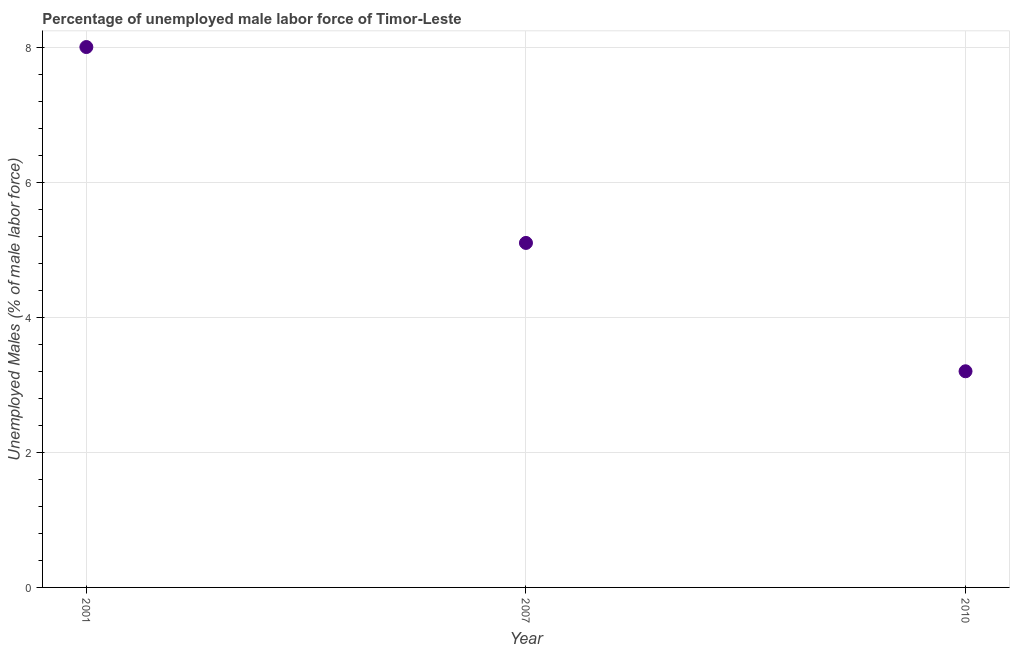What is the total unemployed male labour force in 2007?
Ensure brevity in your answer.  5.1. Across all years, what is the maximum total unemployed male labour force?
Keep it short and to the point. 8. Across all years, what is the minimum total unemployed male labour force?
Give a very brief answer. 3.2. In which year was the total unemployed male labour force maximum?
Offer a terse response. 2001. In which year was the total unemployed male labour force minimum?
Your answer should be compact. 2010. What is the sum of the total unemployed male labour force?
Your answer should be very brief. 16.3. What is the difference between the total unemployed male labour force in 2007 and 2010?
Offer a terse response. 1.9. What is the average total unemployed male labour force per year?
Provide a succinct answer. 5.43. What is the median total unemployed male labour force?
Your answer should be compact. 5.1. Do a majority of the years between 2001 and 2007 (inclusive) have total unemployed male labour force greater than 4 %?
Offer a terse response. Yes. What is the ratio of the total unemployed male labour force in 2007 to that in 2010?
Your answer should be very brief. 1.59. Is the total unemployed male labour force in 2001 less than that in 2010?
Your answer should be compact. No. What is the difference between the highest and the second highest total unemployed male labour force?
Offer a very short reply. 2.9. What is the difference between the highest and the lowest total unemployed male labour force?
Offer a terse response. 4.8. In how many years, is the total unemployed male labour force greater than the average total unemployed male labour force taken over all years?
Your answer should be very brief. 1. How many dotlines are there?
Offer a very short reply. 1. What is the difference between two consecutive major ticks on the Y-axis?
Keep it short and to the point. 2. Are the values on the major ticks of Y-axis written in scientific E-notation?
Keep it short and to the point. No. Does the graph contain grids?
Ensure brevity in your answer.  Yes. What is the title of the graph?
Offer a very short reply. Percentage of unemployed male labor force of Timor-Leste. What is the label or title of the Y-axis?
Keep it short and to the point. Unemployed Males (% of male labor force). What is the Unemployed Males (% of male labor force) in 2001?
Give a very brief answer. 8. What is the Unemployed Males (% of male labor force) in 2007?
Provide a succinct answer. 5.1. What is the Unemployed Males (% of male labor force) in 2010?
Your answer should be very brief. 3.2. What is the difference between the Unemployed Males (% of male labor force) in 2001 and 2010?
Offer a terse response. 4.8. What is the ratio of the Unemployed Males (% of male labor force) in 2001 to that in 2007?
Offer a very short reply. 1.57. What is the ratio of the Unemployed Males (% of male labor force) in 2007 to that in 2010?
Offer a very short reply. 1.59. 